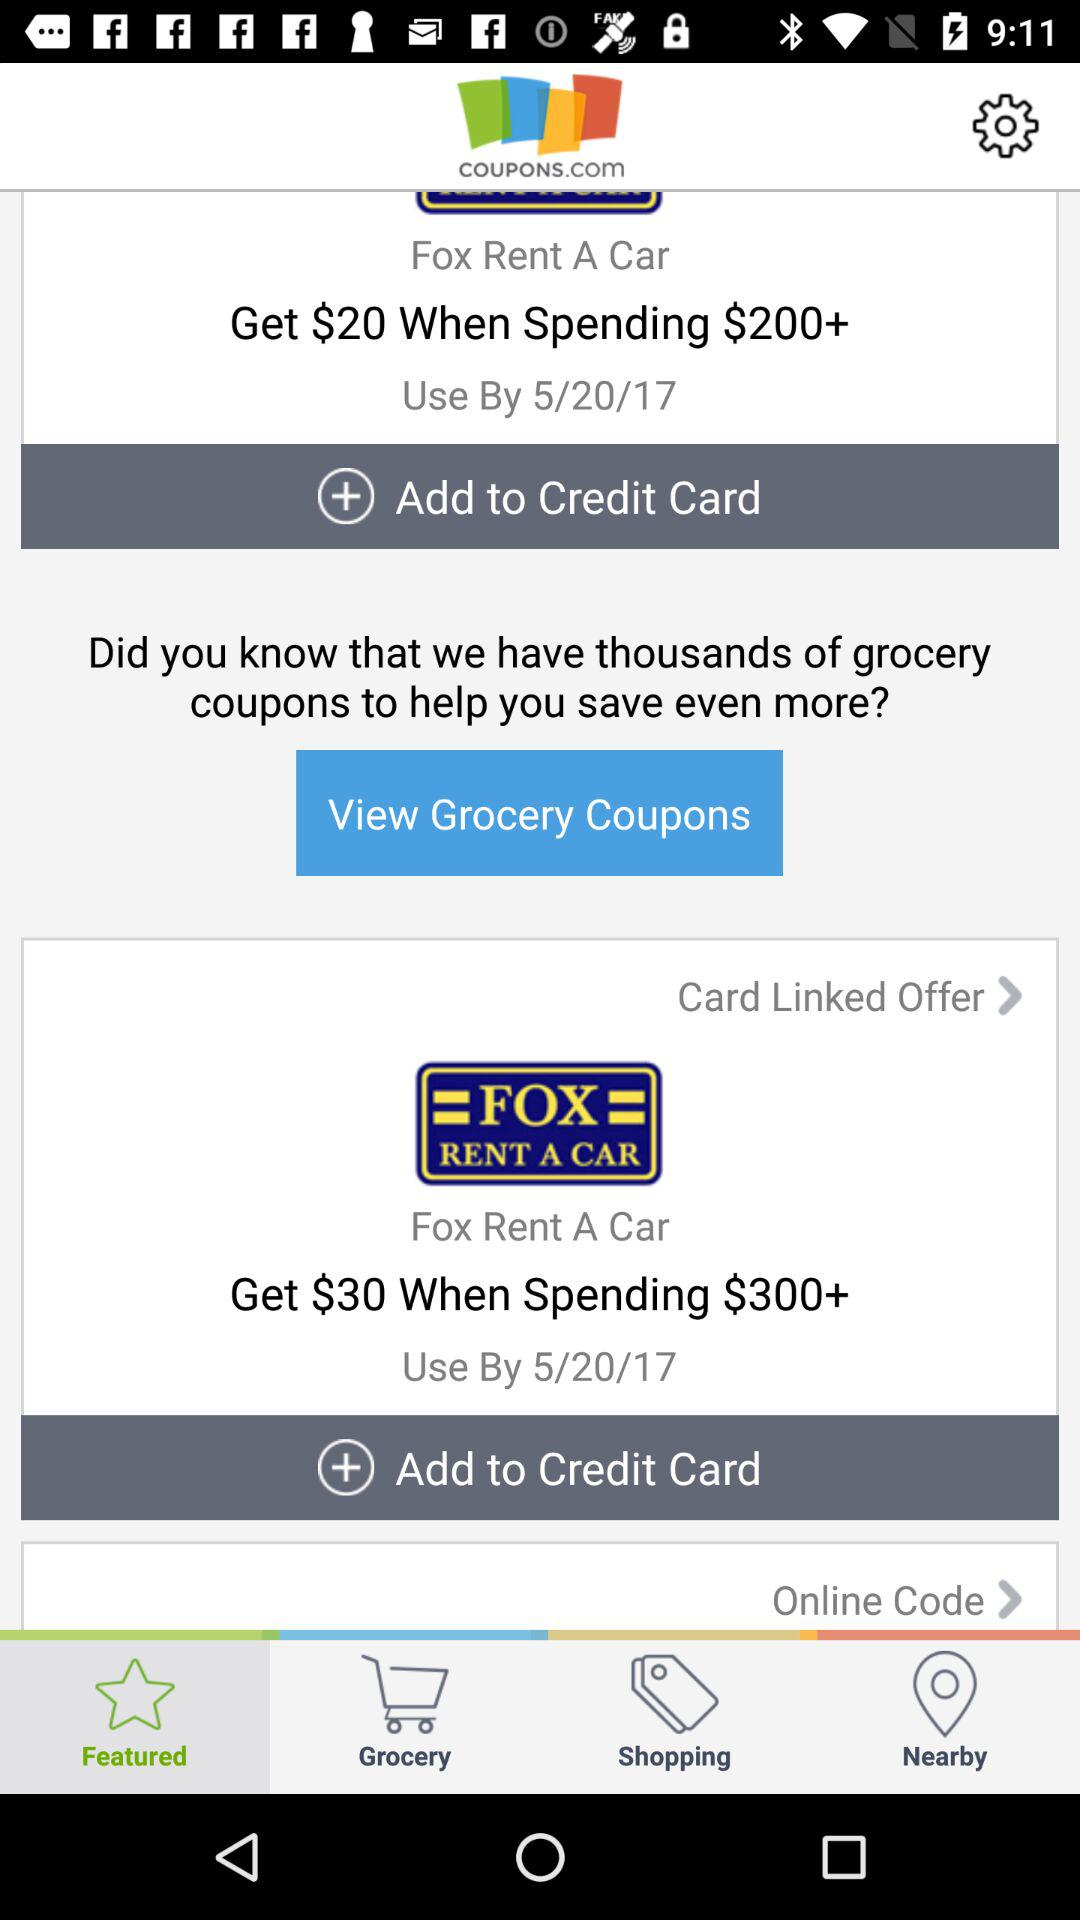What is the name of the application? The name of the application is "Fox Rent A Car". 